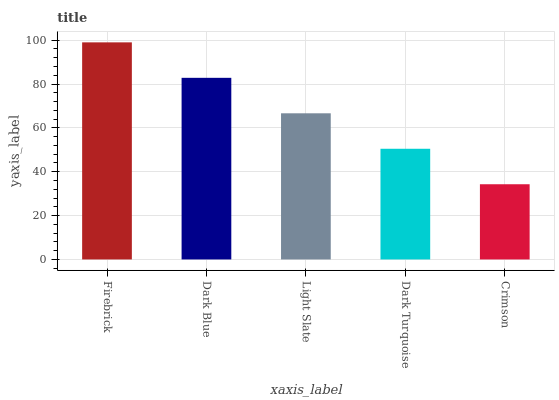Is Crimson the minimum?
Answer yes or no. Yes. Is Firebrick the maximum?
Answer yes or no. Yes. Is Dark Blue the minimum?
Answer yes or no. No. Is Dark Blue the maximum?
Answer yes or no. No. Is Firebrick greater than Dark Blue?
Answer yes or no. Yes. Is Dark Blue less than Firebrick?
Answer yes or no. Yes. Is Dark Blue greater than Firebrick?
Answer yes or no. No. Is Firebrick less than Dark Blue?
Answer yes or no. No. Is Light Slate the high median?
Answer yes or no. Yes. Is Light Slate the low median?
Answer yes or no. Yes. Is Firebrick the high median?
Answer yes or no. No. Is Crimson the low median?
Answer yes or no. No. 